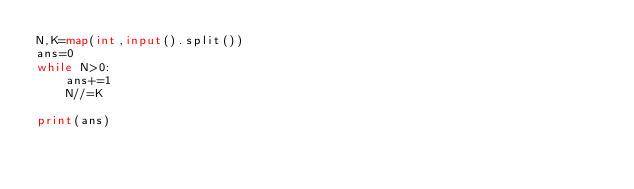<code> <loc_0><loc_0><loc_500><loc_500><_Python_>N,K=map(int,input().split())
ans=0
while N>0:
    ans+=1
    N//=K

print(ans)
</code> 